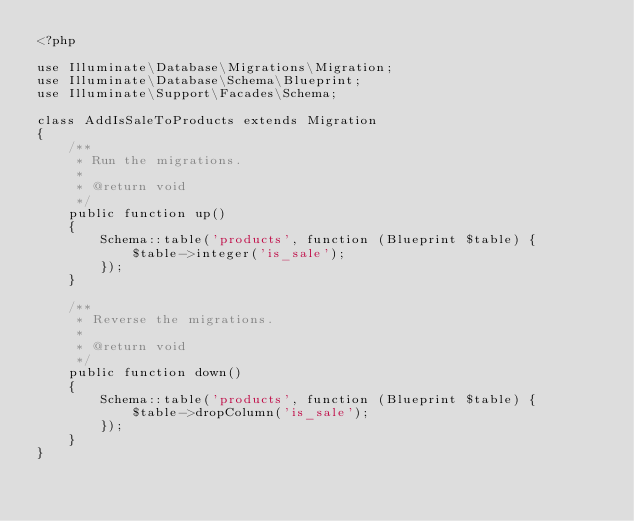Convert code to text. <code><loc_0><loc_0><loc_500><loc_500><_PHP_><?php

use Illuminate\Database\Migrations\Migration;
use Illuminate\Database\Schema\Blueprint;
use Illuminate\Support\Facades\Schema;

class AddIsSaleToProducts extends Migration
{
    /**
     * Run the migrations.
     *
     * @return void
     */
    public function up()
    {
        Schema::table('products', function (Blueprint $table) {
            $table->integer('is_sale');
        });
    }

    /**
     * Reverse the migrations.
     *
     * @return void
     */
    public function down()
    {
        Schema::table('products', function (Blueprint $table) {
            $table->dropColumn('is_sale');
        });
    }
}
</code> 